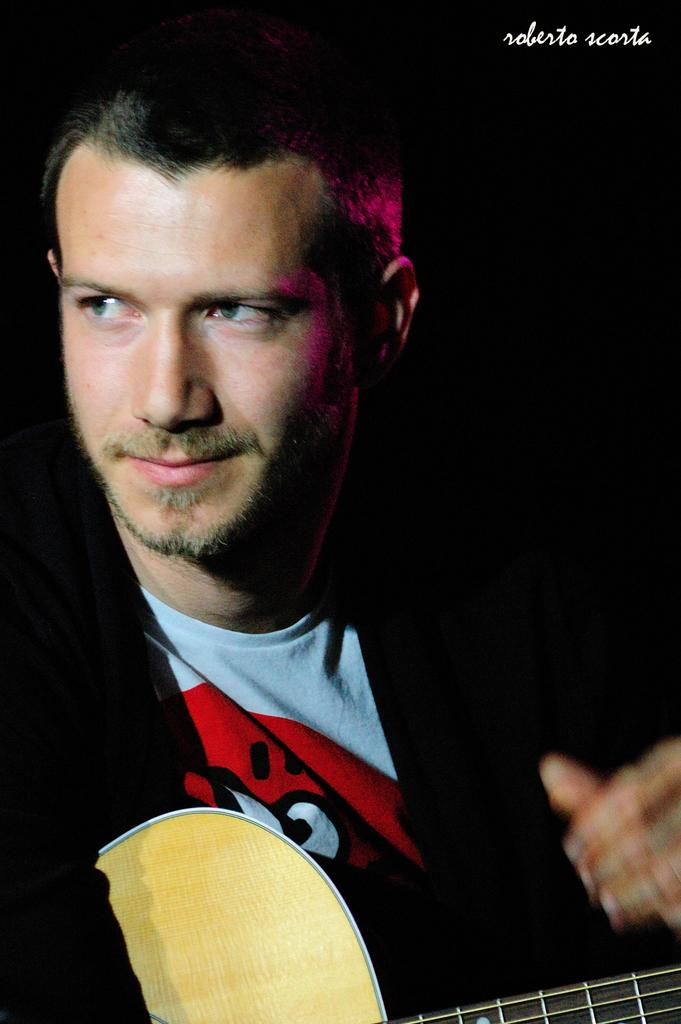What is the main subject of the image? There is a person in the image. What is the person wearing? The person is wearing a black coat and a white T-shirt. What is the person holding in the image? The person is holding a guitar. How many oranges are visible in the image? There are no oranges present in the image. What season is depicted in the image? The image does not depict a specific season, as there is no information about the weather or time of year. 